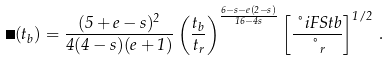<formula> <loc_0><loc_0><loc_500><loc_500>\Gamma ( t _ { b } ) = \frac { ( 5 + e - s ) ^ { 2 } } { 4 ( 4 - s ) ( e + 1 ) } \left ( \frac { t _ { b } } { t _ { r } } \right ) ^ { \frac { 6 - s - e ( 2 - s ) } { 1 6 - 4 s } } \left [ \frac { \nu i F S t b } { \nu _ { r } } \right ] ^ { 1 / 2 } \, .</formula> 